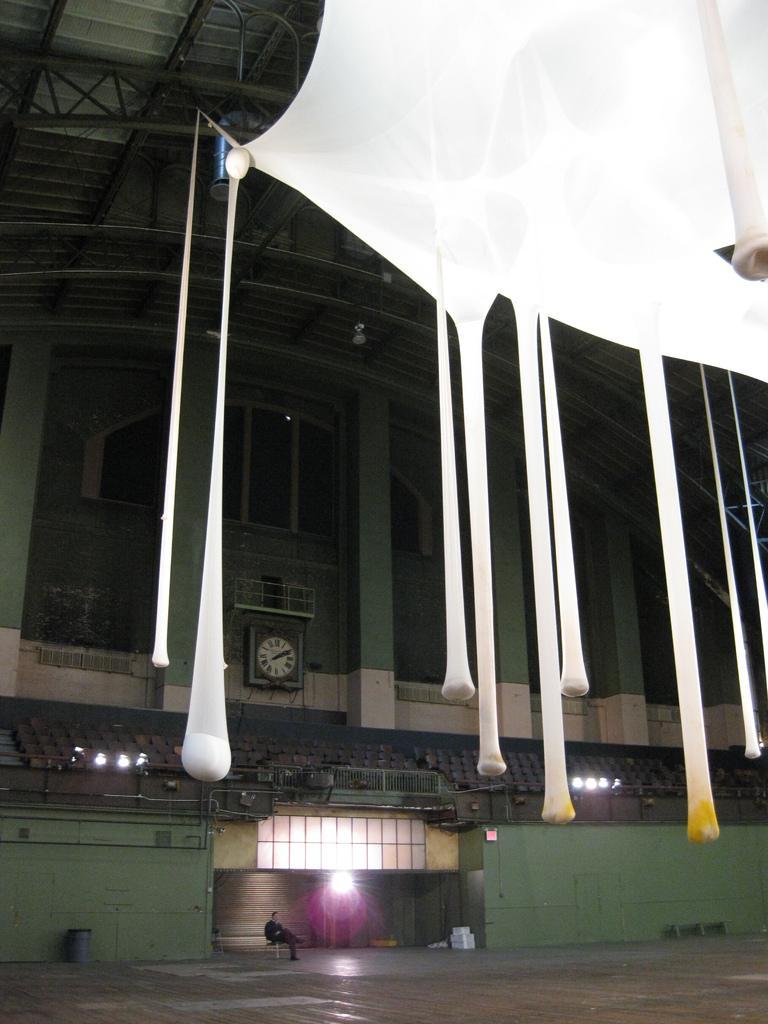Can you describe this image briefly? This is a inside picture of a building. There is a person sitting on a chair. There is wall. There are chairs. In the background of the image there is wall. There is a clock on the wall. At the top of the image there is a ceiling. There is a white color cloth. 